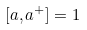<formula> <loc_0><loc_0><loc_500><loc_500>[ a , a ^ { + } ] = 1</formula> 